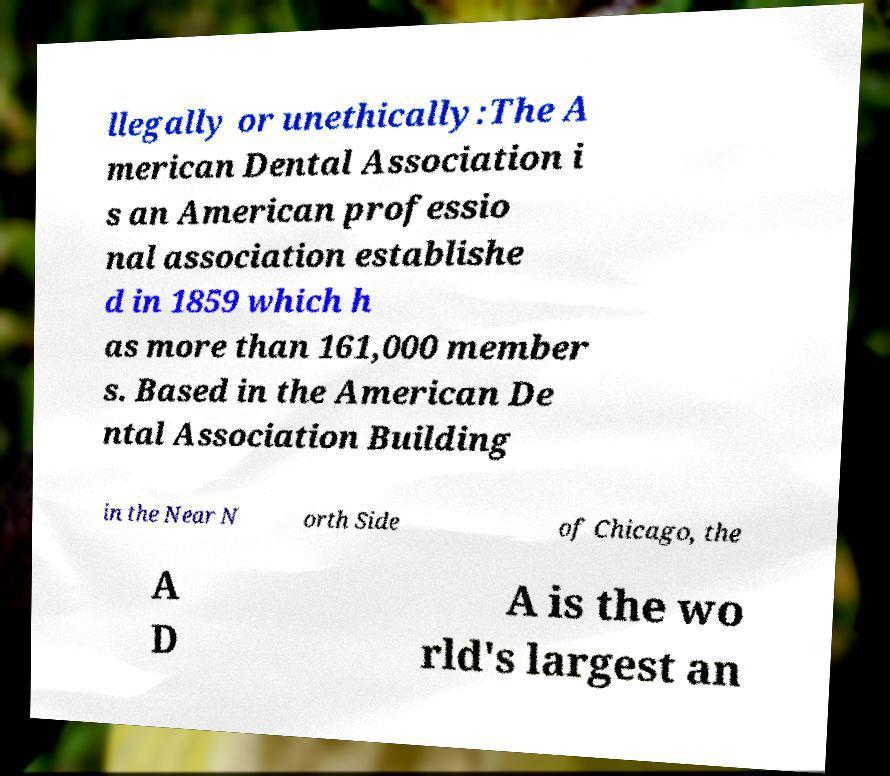Can you accurately transcribe the text from the provided image for me? llegally or unethically:The A merican Dental Association i s an American professio nal association establishe d in 1859 which h as more than 161,000 member s. Based in the American De ntal Association Building in the Near N orth Side of Chicago, the A D A is the wo rld's largest an 